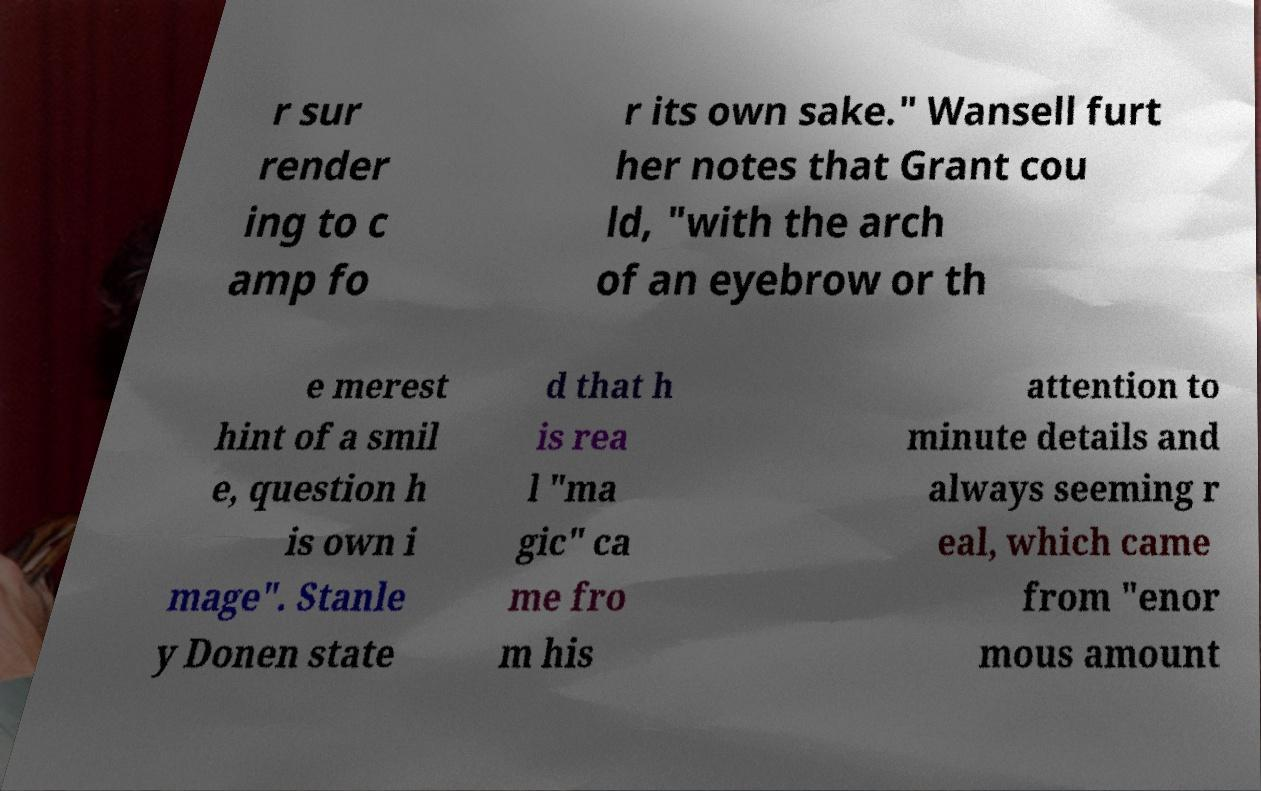Can you accurately transcribe the text from the provided image for me? r sur render ing to c amp fo r its own sake." Wansell furt her notes that Grant cou ld, "with the arch of an eyebrow or th e merest hint of a smil e, question h is own i mage". Stanle y Donen state d that h is rea l "ma gic" ca me fro m his attention to minute details and always seeming r eal, which came from "enor mous amount 